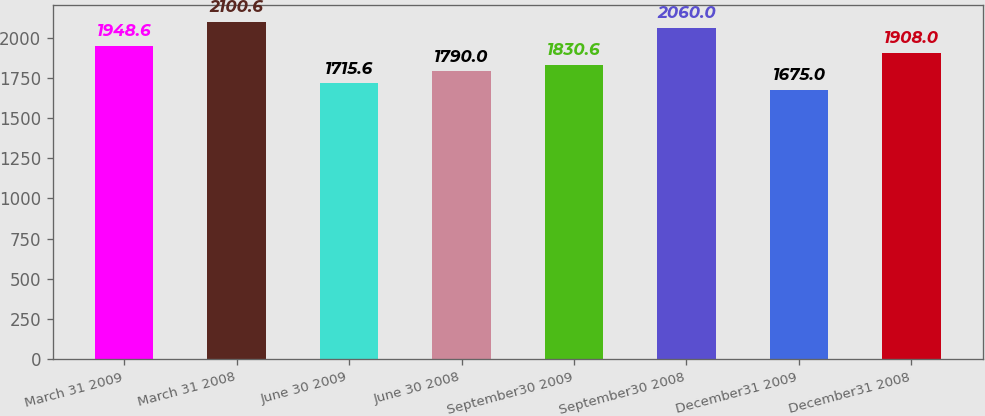<chart> <loc_0><loc_0><loc_500><loc_500><bar_chart><fcel>March 31 2009<fcel>March 31 2008<fcel>June 30 2009<fcel>June 30 2008<fcel>September30 2009<fcel>September30 2008<fcel>December31 2009<fcel>December31 2008<nl><fcel>1948.6<fcel>2100.6<fcel>1715.6<fcel>1790<fcel>1830.6<fcel>2060<fcel>1675<fcel>1908<nl></chart> 